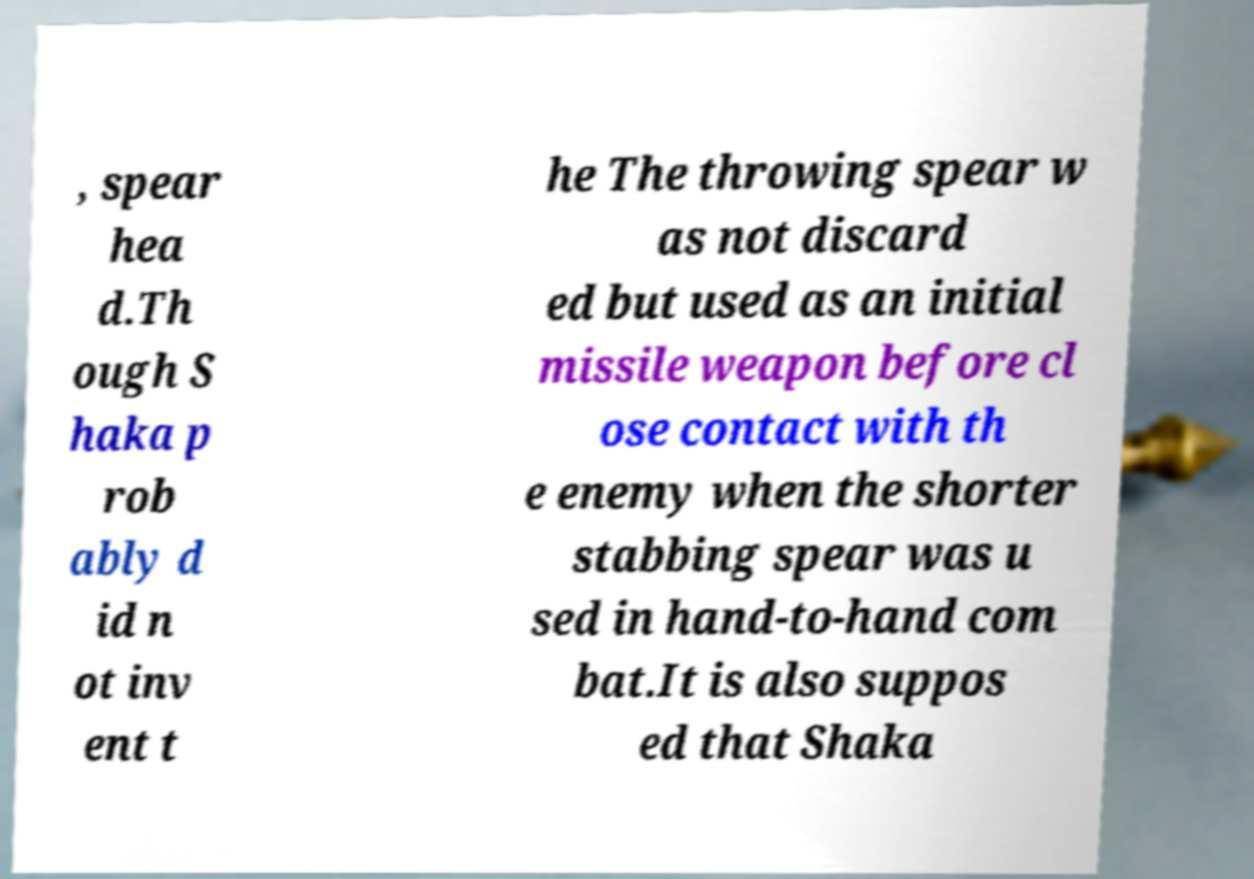What messages or text are displayed in this image? I need them in a readable, typed format. , spear hea d.Th ough S haka p rob ably d id n ot inv ent t he The throwing spear w as not discard ed but used as an initial missile weapon before cl ose contact with th e enemy when the shorter stabbing spear was u sed in hand-to-hand com bat.It is also suppos ed that Shaka 